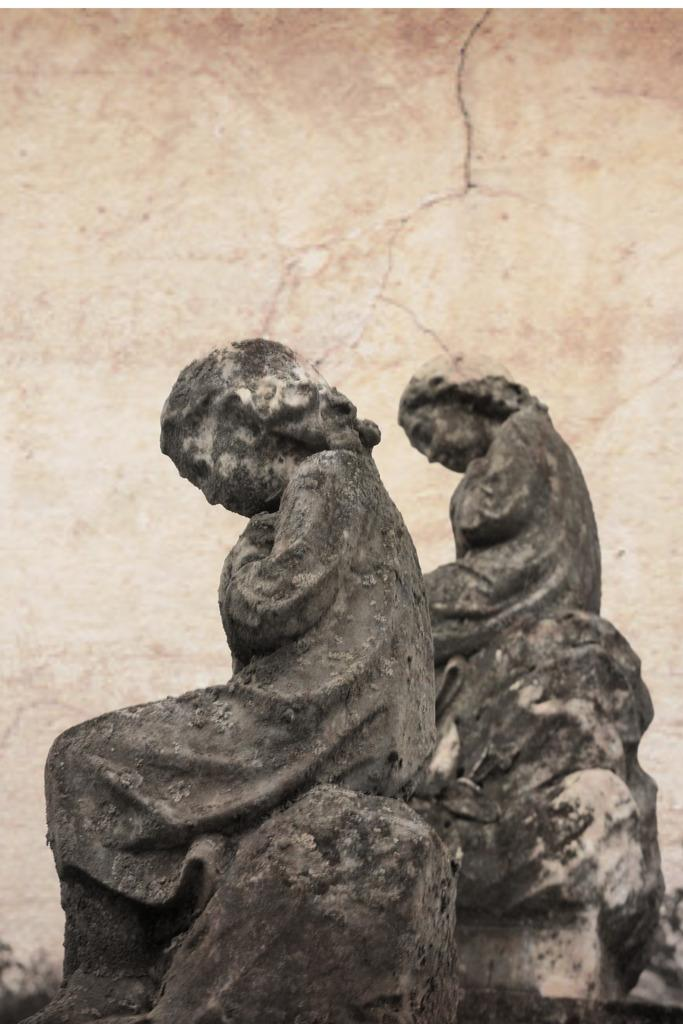How many statues are present in the image? There are two statues in the image. Where are the statues located in the image? The statues are at the bottom of the image. What is visible behind the statues in the image? There is a wall visible in the image behind the statues. What type of cheese is being used to hold up the statues in the image? There is no cheese present in the image, and the statues are not being held up by any cheese. 